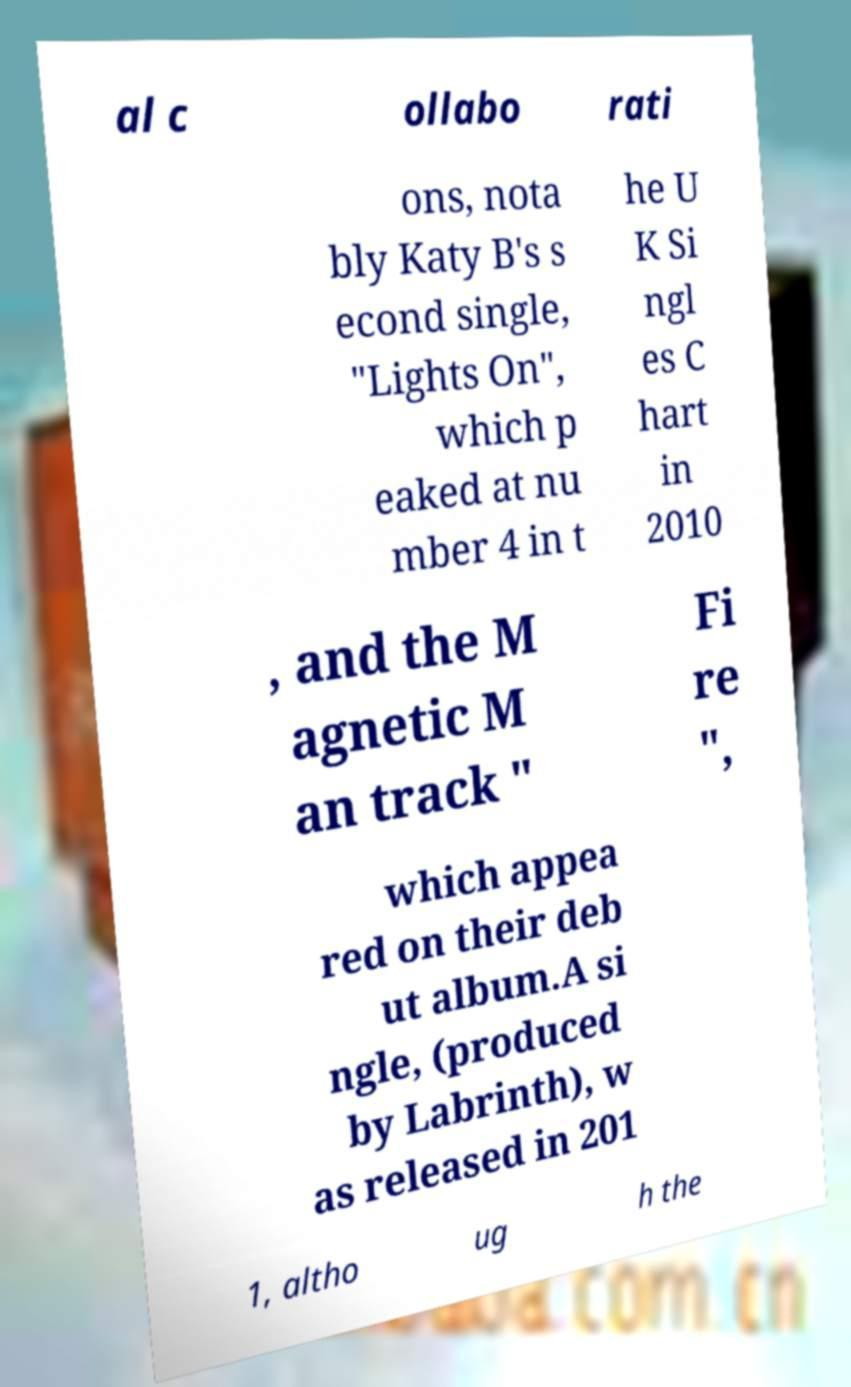Could you extract and type out the text from this image? al c ollabo rati ons, nota bly Katy B's s econd single, "Lights On", which p eaked at nu mber 4 in t he U K Si ngl es C hart in 2010 , and the M agnetic M an track " Fi re ", which appea red on their deb ut album.A si ngle, (produced by Labrinth), w as released in 201 1, altho ug h the 